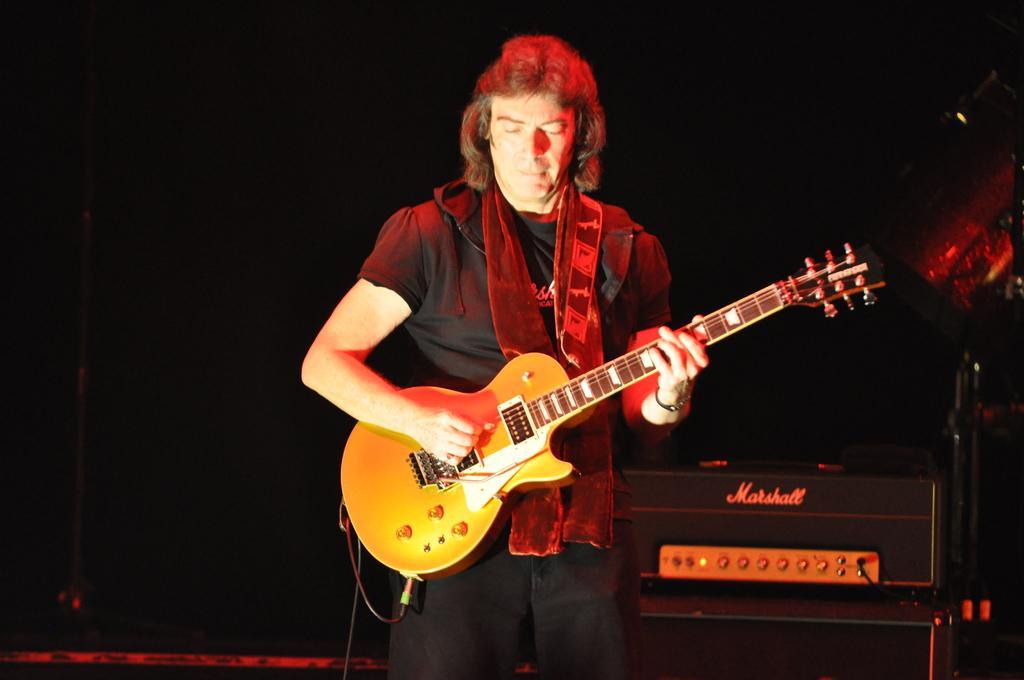In one or two sentences, can you explain what this image depicts? A man is standing and playing guitar behind him there is an electronic device. 